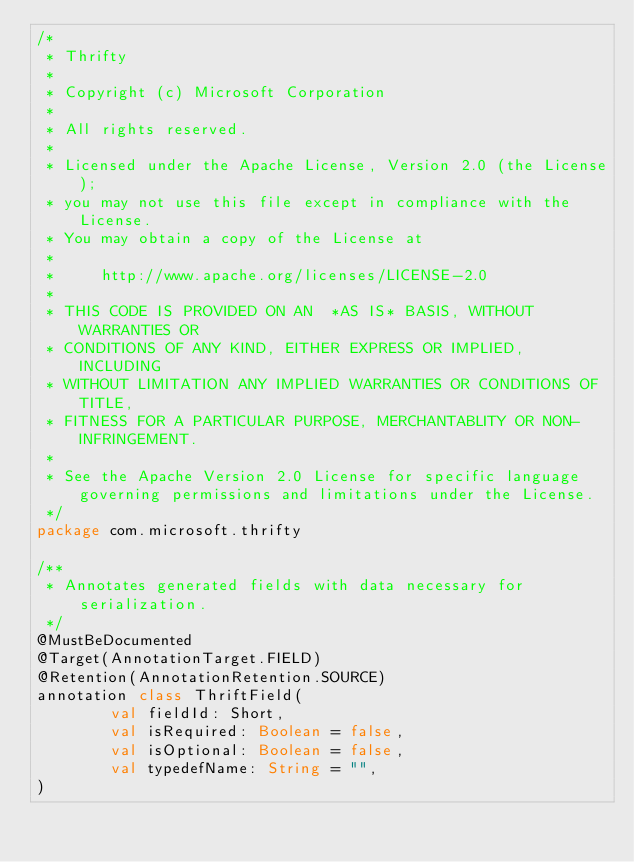Convert code to text. <code><loc_0><loc_0><loc_500><loc_500><_Kotlin_>/*
 * Thrifty
 *
 * Copyright (c) Microsoft Corporation
 *
 * All rights reserved.
 *
 * Licensed under the Apache License, Version 2.0 (the License);
 * you may not use this file except in compliance with the License.
 * You may obtain a copy of the License at
 *
 *     http://www.apache.org/licenses/LICENSE-2.0
 *
 * THIS CODE IS PROVIDED ON AN  *AS IS* BASIS, WITHOUT WARRANTIES OR
 * CONDITIONS OF ANY KIND, EITHER EXPRESS OR IMPLIED, INCLUDING
 * WITHOUT LIMITATION ANY IMPLIED WARRANTIES OR CONDITIONS OF TITLE,
 * FITNESS FOR A PARTICULAR PURPOSE, MERCHANTABLITY OR NON-INFRINGEMENT.
 *
 * See the Apache Version 2.0 License for specific language governing permissions and limitations under the License.
 */
package com.microsoft.thrifty

/**
 * Annotates generated fields with data necessary for serialization.
 */
@MustBeDocumented
@Target(AnnotationTarget.FIELD)
@Retention(AnnotationRetention.SOURCE)
annotation class ThriftField(
        val fieldId: Short,
        val isRequired: Boolean = false,
        val isOptional: Boolean = false,
        val typedefName: String = "",
)
</code> 